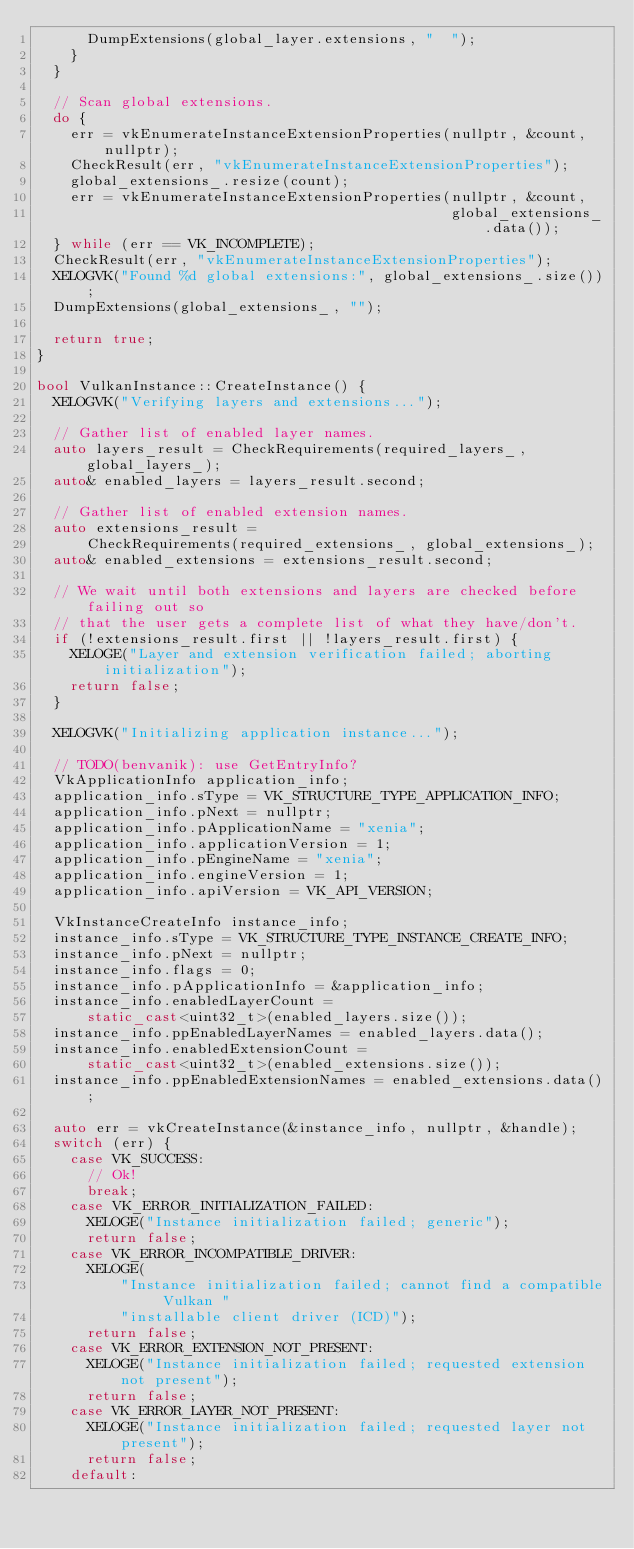Convert code to text. <code><loc_0><loc_0><loc_500><loc_500><_C++_>      DumpExtensions(global_layer.extensions, "  ");
    }
  }

  // Scan global extensions.
  do {
    err = vkEnumerateInstanceExtensionProperties(nullptr, &count, nullptr);
    CheckResult(err, "vkEnumerateInstanceExtensionProperties");
    global_extensions_.resize(count);
    err = vkEnumerateInstanceExtensionProperties(nullptr, &count,
                                                 global_extensions_.data());
  } while (err == VK_INCOMPLETE);
  CheckResult(err, "vkEnumerateInstanceExtensionProperties");
  XELOGVK("Found %d global extensions:", global_extensions_.size());
  DumpExtensions(global_extensions_, "");

  return true;
}

bool VulkanInstance::CreateInstance() {
  XELOGVK("Verifying layers and extensions...");

  // Gather list of enabled layer names.
  auto layers_result = CheckRequirements(required_layers_, global_layers_);
  auto& enabled_layers = layers_result.second;

  // Gather list of enabled extension names.
  auto extensions_result =
      CheckRequirements(required_extensions_, global_extensions_);
  auto& enabled_extensions = extensions_result.second;

  // We wait until both extensions and layers are checked before failing out so
  // that the user gets a complete list of what they have/don't.
  if (!extensions_result.first || !layers_result.first) {
    XELOGE("Layer and extension verification failed; aborting initialization");
    return false;
  }

  XELOGVK("Initializing application instance...");

  // TODO(benvanik): use GetEntryInfo?
  VkApplicationInfo application_info;
  application_info.sType = VK_STRUCTURE_TYPE_APPLICATION_INFO;
  application_info.pNext = nullptr;
  application_info.pApplicationName = "xenia";
  application_info.applicationVersion = 1;
  application_info.pEngineName = "xenia";
  application_info.engineVersion = 1;
  application_info.apiVersion = VK_API_VERSION;

  VkInstanceCreateInfo instance_info;
  instance_info.sType = VK_STRUCTURE_TYPE_INSTANCE_CREATE_INFO;
  instance_info.pNext = nullptr;
  instance_info.flags = 0;
  instance_info.pApplicationInfo = &application_info;
  instance_info.enabledLayerCount =
      static_cast<uint32_t>(enabled_layers.size());
  instance_info.ppEnabledLayerNames = enabled_layers.data();
  instance_info.enabledExtensionCount =
      static_cast<uint32_t>(enabled_extensions.size());
  instance_info.ppEnabledExtensionNames = enabled_extensions.data();

  auto err = vkCreateInstance(&instance_info, nullptr, &handle);
  switch (err) {
    case VK_SUCCESS:
      // Ok!
      break;
    case VK_ERROR_INITIALIZATION_FAILED:
      XELOGE("Instance initialization failed; generic");
      return false;
    case VK_ERROR_INCOMPATIBLE_DRIVER:
      XELOGE(
          "Instance initialization failed; cannot find a compatible Vulkan "
          "installable client driver (ICD)");
      return false;
    case VK_ERROR_EXTENSION_NOT_PRESENT:
      XELOGE("Instance initialization failed; requested extension not present");
      return false;
    case VK_ERROR_LAYER_NOT_PRESENT:
      XELOGE("Instance initialization failed; requested layer not present");
      return false;
    default:</code> 